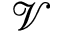<formula> <loc_0><loc_0><loc_500><loc_500>\mathcal { V }</formula> 